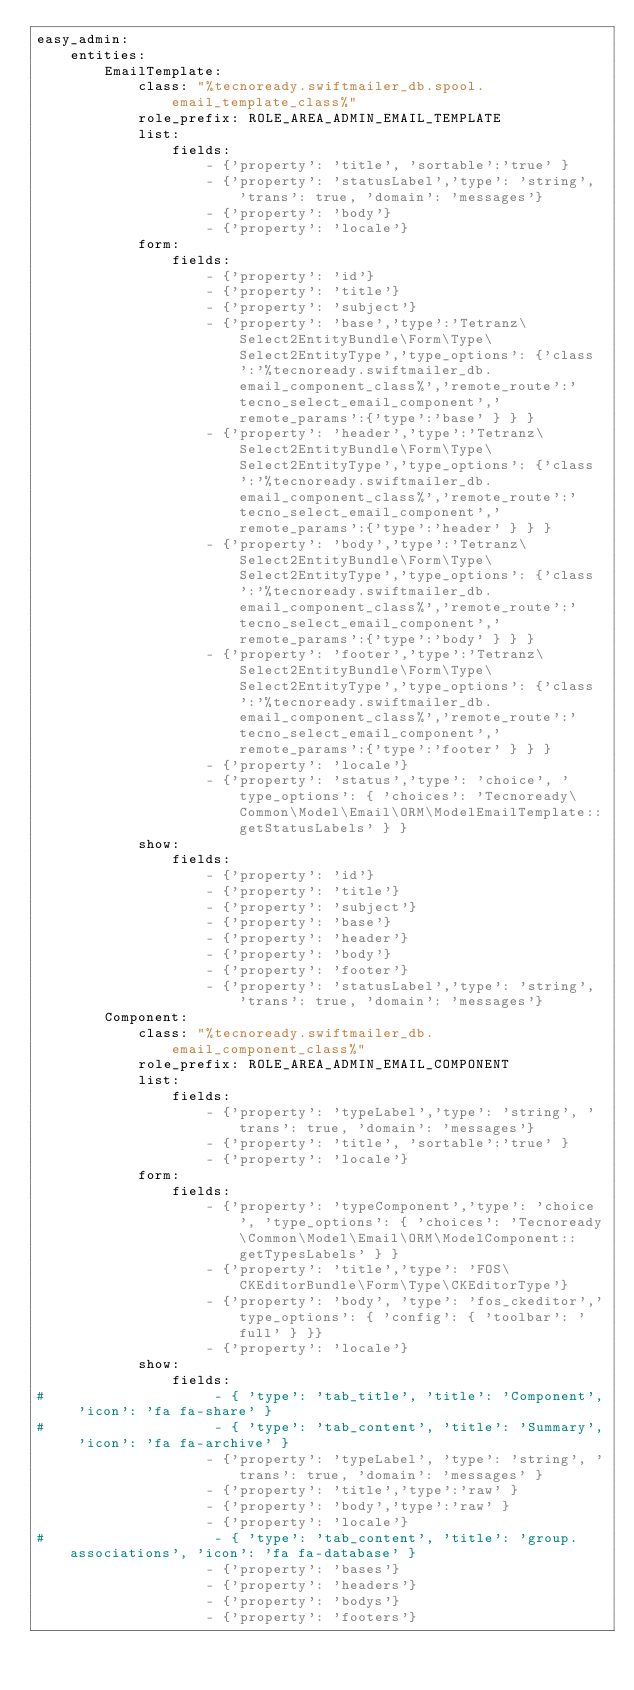<code> <loc_0><loc_0><loc_500><loc_500><_YAML_>easy_admin:
    entities:
        EmailTemplate:
            class: "%tecnoready.swiftmailer_db.spool.email_template_class%"
            role_prefix: ROLE_AREA_ADMIN_EMAIL_TEMPLATE
            list:
                fields: 
                    - {'property': 'title', 'sortable':'true' }
                    - {'property': 'statusLabel','type': 'string', 'trans': true, 'domain': 'messages'}
                    - {'property': 'body'}
                    - {'property': 'locale'}
            form:  
                fields:  
                    - {'property': 'id'}
                    - {'property': 'title'}
                    - {'property': 'subject'}
                    - {'property': 'base','type':'Tetranz\Select2EntityBundle\Form\Type\Select2EntityType','type_options': {'class':'%tecnoready.swiftmailer_db.email_component_class%','remote_route':'tecno_select_email_component','remote_params':{'type':'base' } } }
                    - {'property': 'header','type':'Tetranz\Select2EntityBundle\Form\Type\Select2EntityType','type_options': {'class':'%tecnoready.swiftmailer_db.email_component_class%','remote_route':'tecno_select_email_component','remote_params':{'type':'header' } } }
                    - {'property': 'body','type':'Tetranz\Select2EntityBundle\Form\Type\Select2EntityType','type_options': {'class':'%tecnoready.swiftmailer_db.email_component_class%','remote_route':'tecno_select_email_component','remote_params':{'type':'body' } } }
                    - {'property': 'footer','type':'Tetranz\Select2EntityBundle\Form\Type\Select2EntityType','type_options': {'class':'%tecnoready.swiftmailer_db.email_component_class%','remote_route':'tecno_select_email_component','remote_params':{'type':'footer' } } }
                    - {'property': 'locale'}
                    - {'property': 'status','type': 'choice', 'type_options': { 'choices': 'Tecnoready\Common\Model\Email\ORM\ModelEmailTemplate::getStatusLabels' } }
            show:  
                fields:  
                    - {'property': 'id'}
                    - {'property': 'title'}
                    - {'property': 'subject'}
                    - {'property': 'base'}
                    - {'property': 'header'}
                    - {'property': 'body'}
                    - {'property': 'footer'}
                    - {'property': 'statusLabel','type': 'string', 'trans': true, 'domain': 'messages'}
        Component:
            class: "%tecnoready.swiftmailer_db.email_component_class%"
            role_prefix: ROLE_AREA_ADMIN_EMAIL_COMPONENT
            list:
                fields: 
                    - {'property': 'typeLabel','type': 'string', 'trans': true, 'domain': 'messages'}
                    - {'property': 'title', 'sortable':'true' }
                    - {'property': 'locale'}
            form:  
                fields:  
                    - {'property': 'typeComponent','type': 'choice', 'type_options': { 'choices': 'Tecnoready\Common\Model\Email\ORM\ModelComponent::getTypesLabels' } }
                    - {'property': 'title','type': 'FOS\CKEditorBundle\Form\Type\CKEditorType'}
                    - {'property': 'body', 'type': 'fos_ckeditor','type_options': { 'config': { 'toolbar': 'full' } }}
                    - {'property': 'locale'}
            show:  
                fields:  
#                    - { 'type': 'tab_title', 'title': 'Component', 'icon': 'fa fa-share' }
#                    - { 'type': 'tab_content', 'title': 'Summary', 'icon': 'fa fa-archive' }
                    - {'property': 'typeLabel', 'type': 'string', 'trans': true, 'domain': 'messages' }
                    - {'property': 'title','type':'raw' }
                    - {'property': 'body','type':'raw' }
                    - {'property': 'locale'}
#                    - { 'type': 'tab_content', 'title': 'group.associations', 'icon': 'fa fa-database' }
                    - {'property': 'bases'}
                    - {'property': 'headers'}
                    - {'property': 'bodys'}
                    - {'property': 'footers'}</code> 